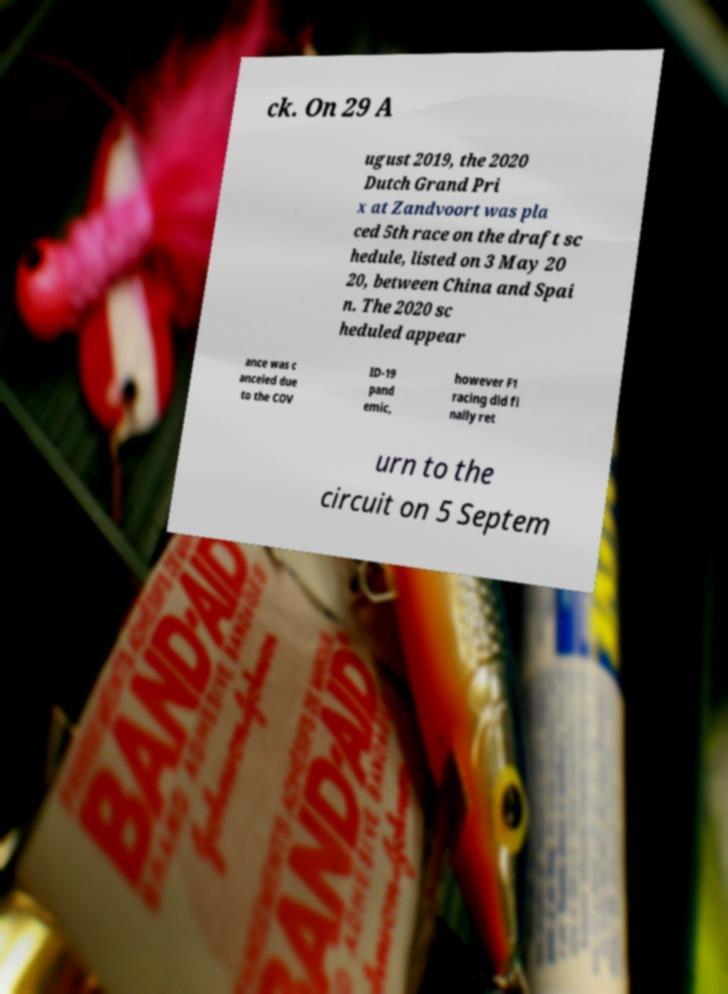What messages or text are displayed in this image? I need them in a readable, typed format. ck. On 29 A ugust 2019, the 2020 Dutch Grand Pri x at Zandvoort was pla ced 5th race on the draft sc hedule, listed on 3 May 20 20, between China and Spai n. The 2020 sc heduled appear ance was c anceled due to the COV ID-19 pand emic, however F1 racing did fi nally ret urn to the circuit on 5 Septem 